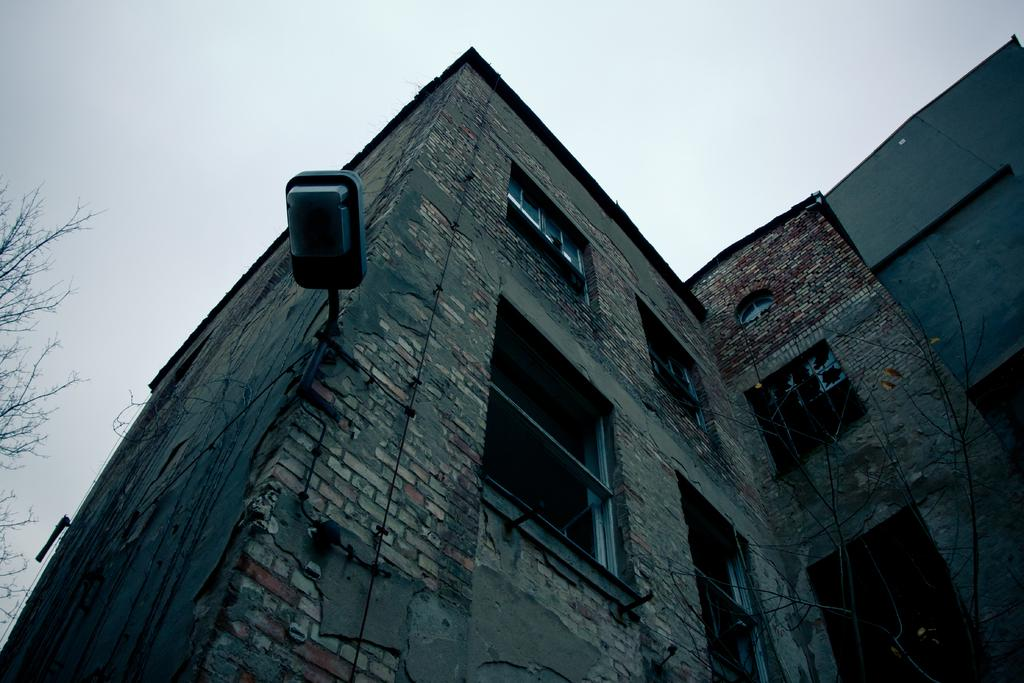What type of material is used to construct the buildings in the image? The buildings in the image are made of red bricks. What is the condition of the trees in the image? The trees in the image are dry. Can you describe the street light in the image? There is a street light attached to a building in the image. What type of plastic animals can be seen in the image? There is no plastic or animals present in the image. Is there a zoo in the image? No, there is no zoo in the image. 